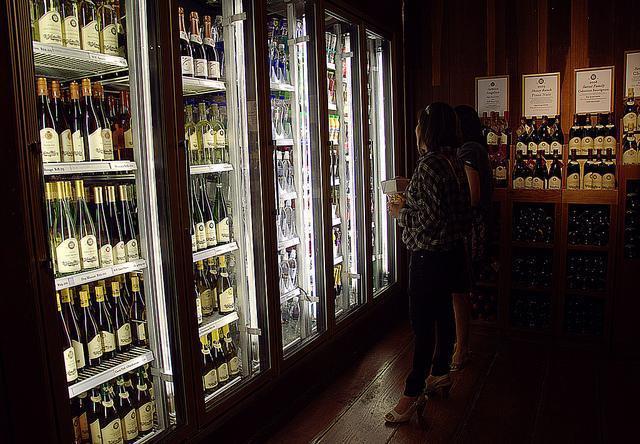How many people are in the picture?
Give a very brief answer. 2. How many refrigerators are visible?
Give a very brief answer. 5. 